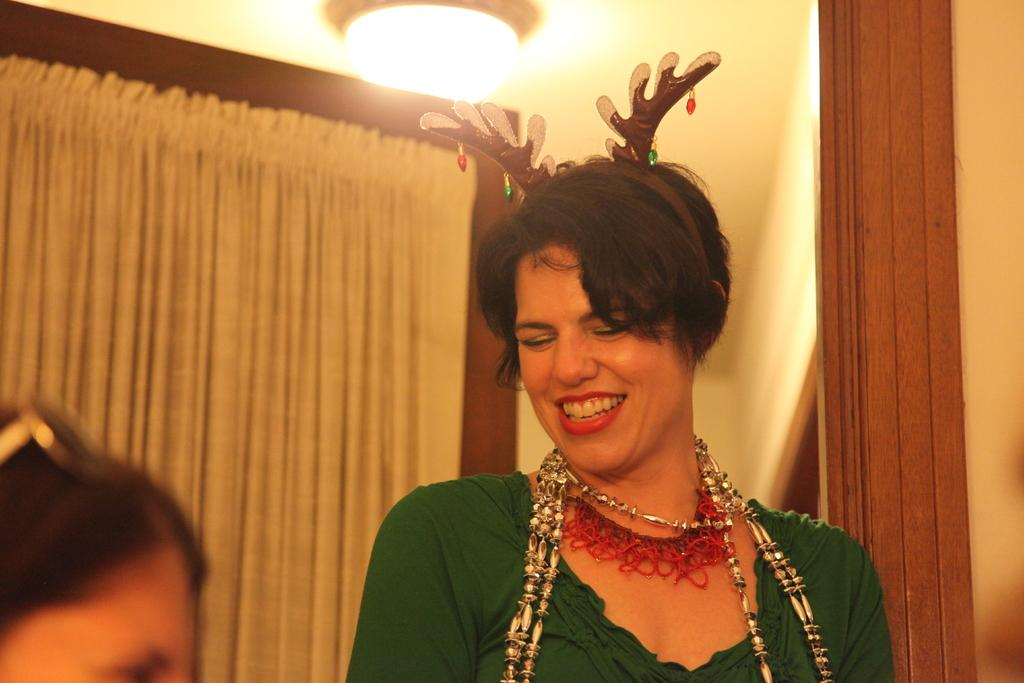Who is the main subject in the middle of the picture? There is a woman in the middle of the picture. What is the woman doing in the image? The woman is smiling in the image. Can you describe the person at the bottom of the picture? There is a person at the bottom of the picture, but their appearance or actions are not specified. What can be seen in the background of the image? There is a curtain, a light, and a wall in the background of the image. What type of pet is visible in the image? There is no pet visible in the image. How does the mist affect the visibility of the subjects in the image? There is no mention of mist in the image, so it cannot affect the visibility of the subjects. 